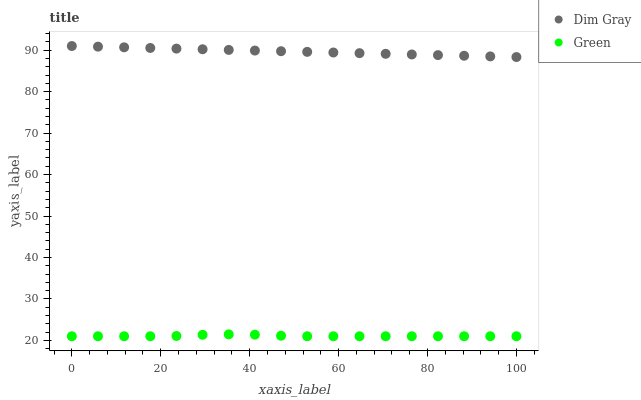Does Green have the minimum area under the curve?
Answer yes or no. Yes. Does Dim Gray have the maximum area under the curve?
Answer yes or no. Yes. Does Green have the maximum area under the curve?
Answer yes or no. No. Is Dim Gray the smoothest?
Answer yes or no. Yes. Is Green the roughest?
Answer yes or no. Yes. Is Green the smoothest?
Answer yes or no. No. Does Green have the lowest value?
Answer yes or no. Yes. Does Dim Gray have the highest value?
Answer yes or no. Yes. Does Green have the highest value?
Answer yes or no. No. Is Green less than Dim Gray?
Answer yes or no. Yes. Is Dim Gray greater than Green?
Answer yes or no. Yes. Does Green intersect Dim Gray?
Answer yes or no. No. 